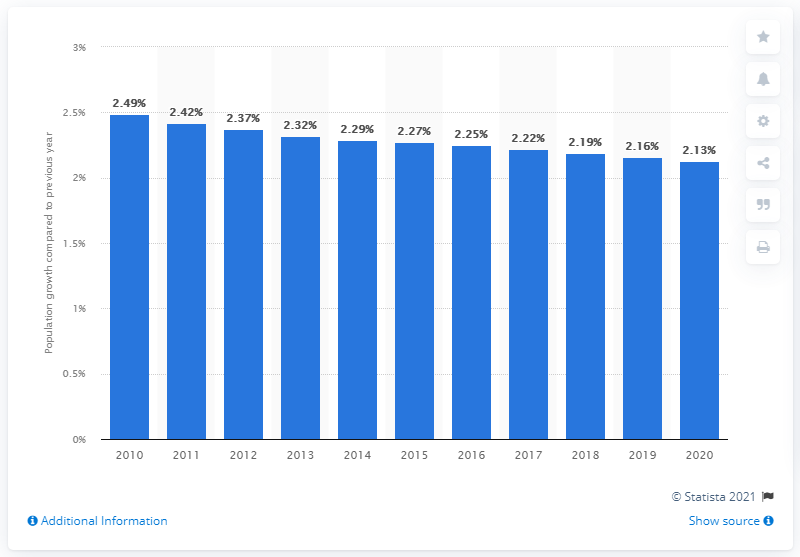Draw attention to some important aspects in this diagram. In 2020, the population of Ghana changed from what it was in 2010. 